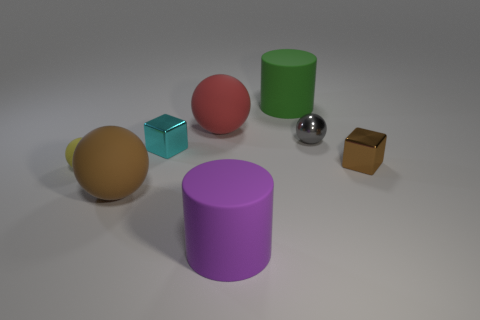Subtract all large red spheres. How many spheres are left? 3 Subtract all yellow spheres. How many spheres are left? 3 Add 1 yellow balls. How many objects exist? 9 Subtract 2 spheres. How many spheres are left? 2 Subtract all cubes. How many objects are left? 6 Subtract all yellow spheres. Subtract all green blocks. How many spheres are left? 3 Subtract all cyan objects. Subtract all green things. How many objects are left? 6 Add 2 purple things. How many purple things are left? 3 Add 2 brown blocks. How many brown blocks exist? 3 Subtract 0 blue cylinders. How many objects are left? 8 